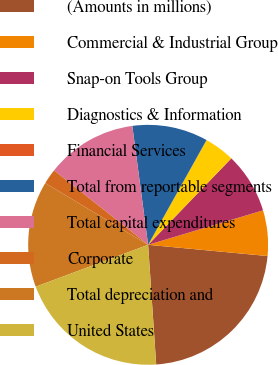Convert chart to OTSL. <chart><loc_0><loc_0><loc_500><loc_500><pie_chart><fcel>(Amounts in millions)<fcel>Commercial & Industrial Group<fcel>Snap-on Tools Group<fcel>Diagnostics & Information<fcel>Financial Services<fcel>Total from reportable segments<fcel>Total capital expenditures<fcel>Corporate<fcel>Total depreciation and<fcel>United States<nl><fcel>22.44%<fcel>6.13%<fcel>8.17%<fcel>4.09%<fcel>0.01%<fcel>10.2%<fcel>12.24%<fcel>2.05%<fcel>14.28%<fcel>20.4%<nl></chart> 